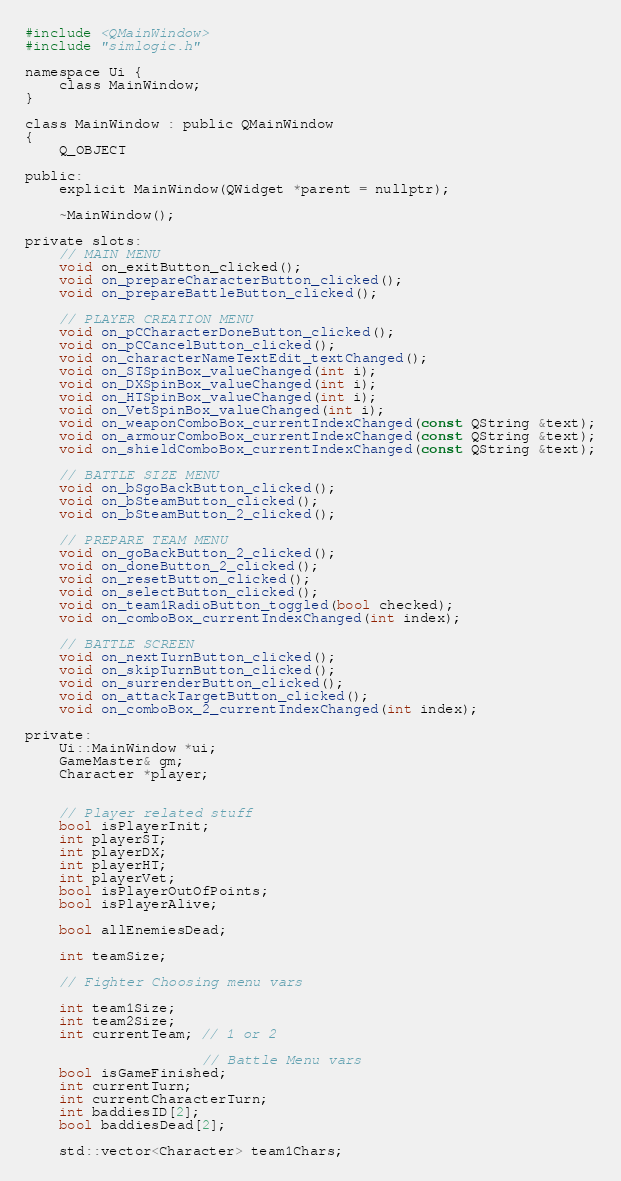<code> <loc_0><loc_0><loc_500><loc_500><_C_>#include <QMainWindow>
#include "simlogic.h"

namespace Ui {
	class MainWindow;
}

class MainWindow : public QMainWindow
{
	Q_OBJECT

public:
	explicit MainWindow(QWidget *parent = nullptr);

	~MainWindow();

private slots:
	// MAIN MENU
	void on_exitButton_clicked();
	void on_prepareCharacterButton_clicked();
	void on_prepareBattleButton_clicked();

	// PLAYER CREATION MENU
	void on_pCCharacterDoneButton_clicked();
	void on_pCCancelButton_clicked();
	void on_characterNameTextEdit_textChanged();
	void on_STSpinBox_valueChanged(int i);
	void on_DXSpinBox_valueChanged(int i);
	void on_HTSpinBox_valueChanged(int i);
	void on_VetSpinBox_valueChanged(int i);
	void on_weaponComboBox_currentIndexChanged(const QString &text);
	void on_armourComboBox_currentIndexChanged(const QString &text);
	void on_shieldComboBox_currentIndexChanged(const QString &text);

	// BATTLE SIZE MENU
	void on_bSgoBackButton_clicked();
	void on_bSteamButton_clicked();
	void on_bSteamButton_2_clicked();

	// PREPARE TEAM MENU
	void on_goBackButton_2_clicked();
	void on_doneButton_2_clicked();
	void on_resetButton_clicked();
	void on_selectButton_clicked();
	void on_team1RadioButton_toggled(bool checked);
	void on_comboBox_currentIndexChanged(int index);

	// BATTLE SCREEN
	void on_nextTurnButton_clicked();
	void on_skipTurnButton_clicked();
	void on_surrenderButton_clicked();
	void on_attackTargetButton_clicked();
	void on_comboBox_2_currentIndexChanged(int index);

private:
	Ui::MainWindow *ui;
	GameMaster& gm;
	Character *player;


	// Player related stuff
	bool isPlayerInit;
	int playerST;
	int playerDX;
	int playerHT;
	int playerVet;
	bool isPlayerOutOfPoints;
	bool isPlayerAlive;

	bool allEnemiesDead;

	int teamSize;

	// Fighter Choosing menu vars

	int team1Size;
	int team2Size;
	int currentTeam; // 1 or 2

					 // Battle Menu vars
	bool isGameFinished;
	int currentTurn;
	int currentCharacterTurn;
	int baddiesID[2];
	bool baddiesDead[2];

	std::vector<Character> team1Chars;</code> 